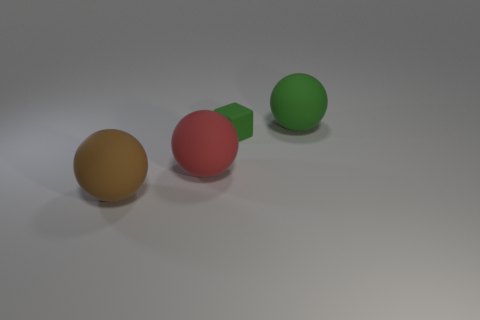Is there anything else that is the same size as the rubber block?
Your answer should be compact. No. Is there another block of the same color as the tiny cube?
Provide a succinct answer. No. There is a red thing that is the same size as the brown ball; what shape is it?
Your answer should be compact. Sphere. There is a tiny green object; are there any matte spheres right of it?
Offer a very short reply. Yes. Do the green object in front of the green sphere and the object that is right of the green cube have the same material?
Make the answer very short. Yes. How many other rubber balls have the same size as the brown sphere?
Keep it short and to the point. 2. What is the shape of the thing that is the same color as the tiny cube?
Give a very brief answer. Sphere. There is a large object that is behind the green matte cube; what material is it?
Your answer should be very brief. Rubber. What number of other tiny objects are the same shape as the brown object?
Your answer should be very brief. 0. What is the shape of the big green object that is the same material as the red sphere?
Ensure brevity in your answer.  Sphere. 